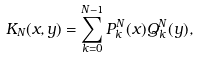Convert formula to latex. <formula><loc_0><loc_0><loc_500><loc_500>K _ { N } ( x , y ) = \sum _ { k = 0 } ^ { N - 1 } P ^ { N } _ { k } ( x ) Q ^ { N } _ { k } ( y ) ,</formula> 